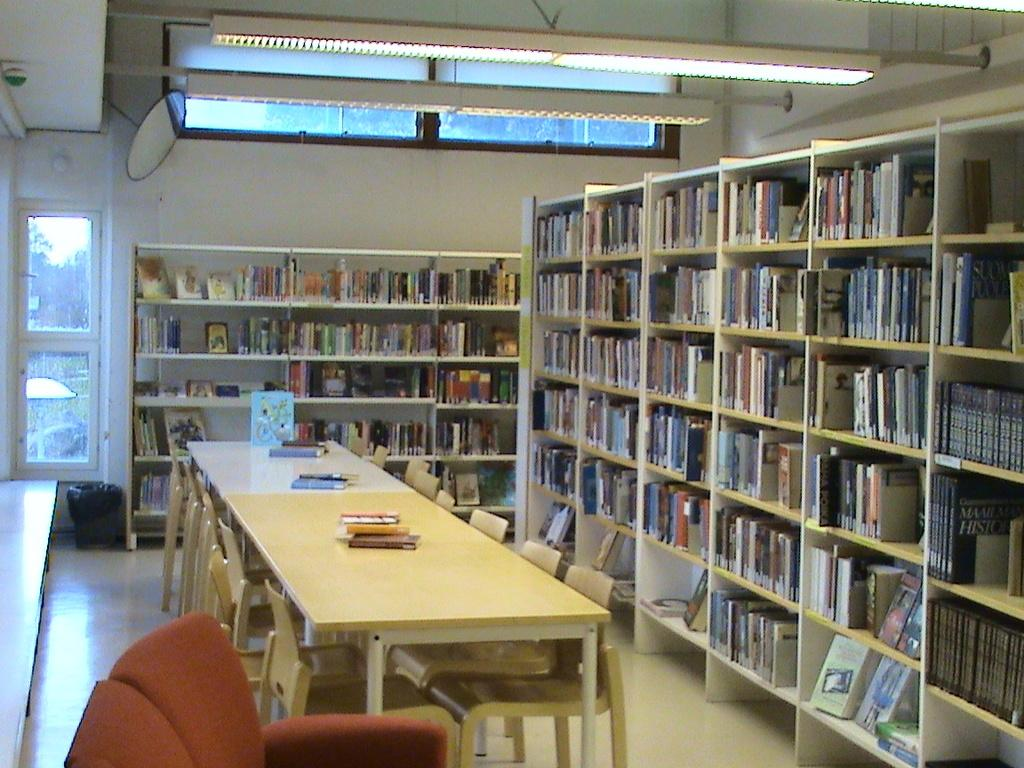<image>
Create a compact narrative representing the image presented. A libraby showing many books, including a set of History Encyclopedias. 